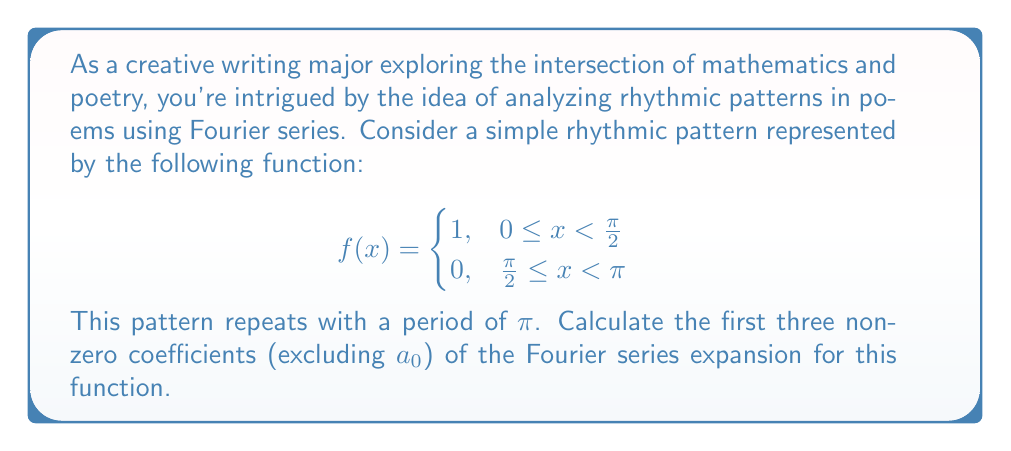Can you solve this math problem? Let's approach this step-by-step:

1) The general form of a Fourier series is:

   $$f(x) = \frac{a_0}{2} + \sum_{n=1}^{\infty} (a_n \cos(nx) + b_n \sin(nx))$$

2) For our function with period $\pi$, the coefficients are given by:

   $$a_n = \frac{2}{\pi} \int_0^{\pi} f(x) \cos(2nx) dx$$
   $$b_n = \frac{2}{\pi} \int_0^{\pi} f(x) \sin(2nx) dx$$

3) Let's start with $b_n$:

   $$b_n = \frac{2}{\pi} \int_0^{\frac{\pi}{2}} \sin(2nx) dx$$

   $$= \frac{2}{\pi} \left[ -\frac{1}{2n} \cos(2nx) \right]_0^{\frac{\pi}{2}}$$

   $$= \frac{1}{n\pi} (1 - \cos(n\pi))$$

4) This simplifies to:

   $$b_n = \begin{cases}
   \frac{2}{n\pi}, & n \text{ odd} \\
   0, & n \text{ even}
   \end{cases}$$

5) Now for $a_n$:

   $$a_n = \frac{2}{\pi} \int_0^{\frac{\pi}{2}} \cos(2nx) dx$$

   $$= \frac{2}{\pi} \left[ \frac{1}{2n} \sin(2nx) \right]_0^{\frac{\pi}{2}}$$

   $$= \frac{1}{n\pi} \sin(n\pi)$$

6) This simplifies to:

   $$a_n = 0 \text{ for all } n$$

7) The first three non-zero coefficients (excluding $a_0$) are:

   $b_1 = \frac{2}{\pi}$
   $b_3 = \frac{2}{3\pi}$
   $b_5 = \frac{2}{5\pi}$
Answer: $b_1 = \frac{2}{\pi}$, $b_3 = \frac{2}{3\pi}$, $b_5 = \frac{2}{5\pi}$ 